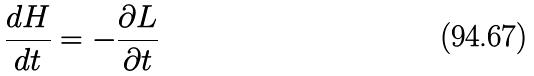Convert formula to latex. <formula><loc_0><loc_0><loc_500><loc_500>\frac { d H } { d t } = - \frac { \partial L } { \partial t }</formula> 